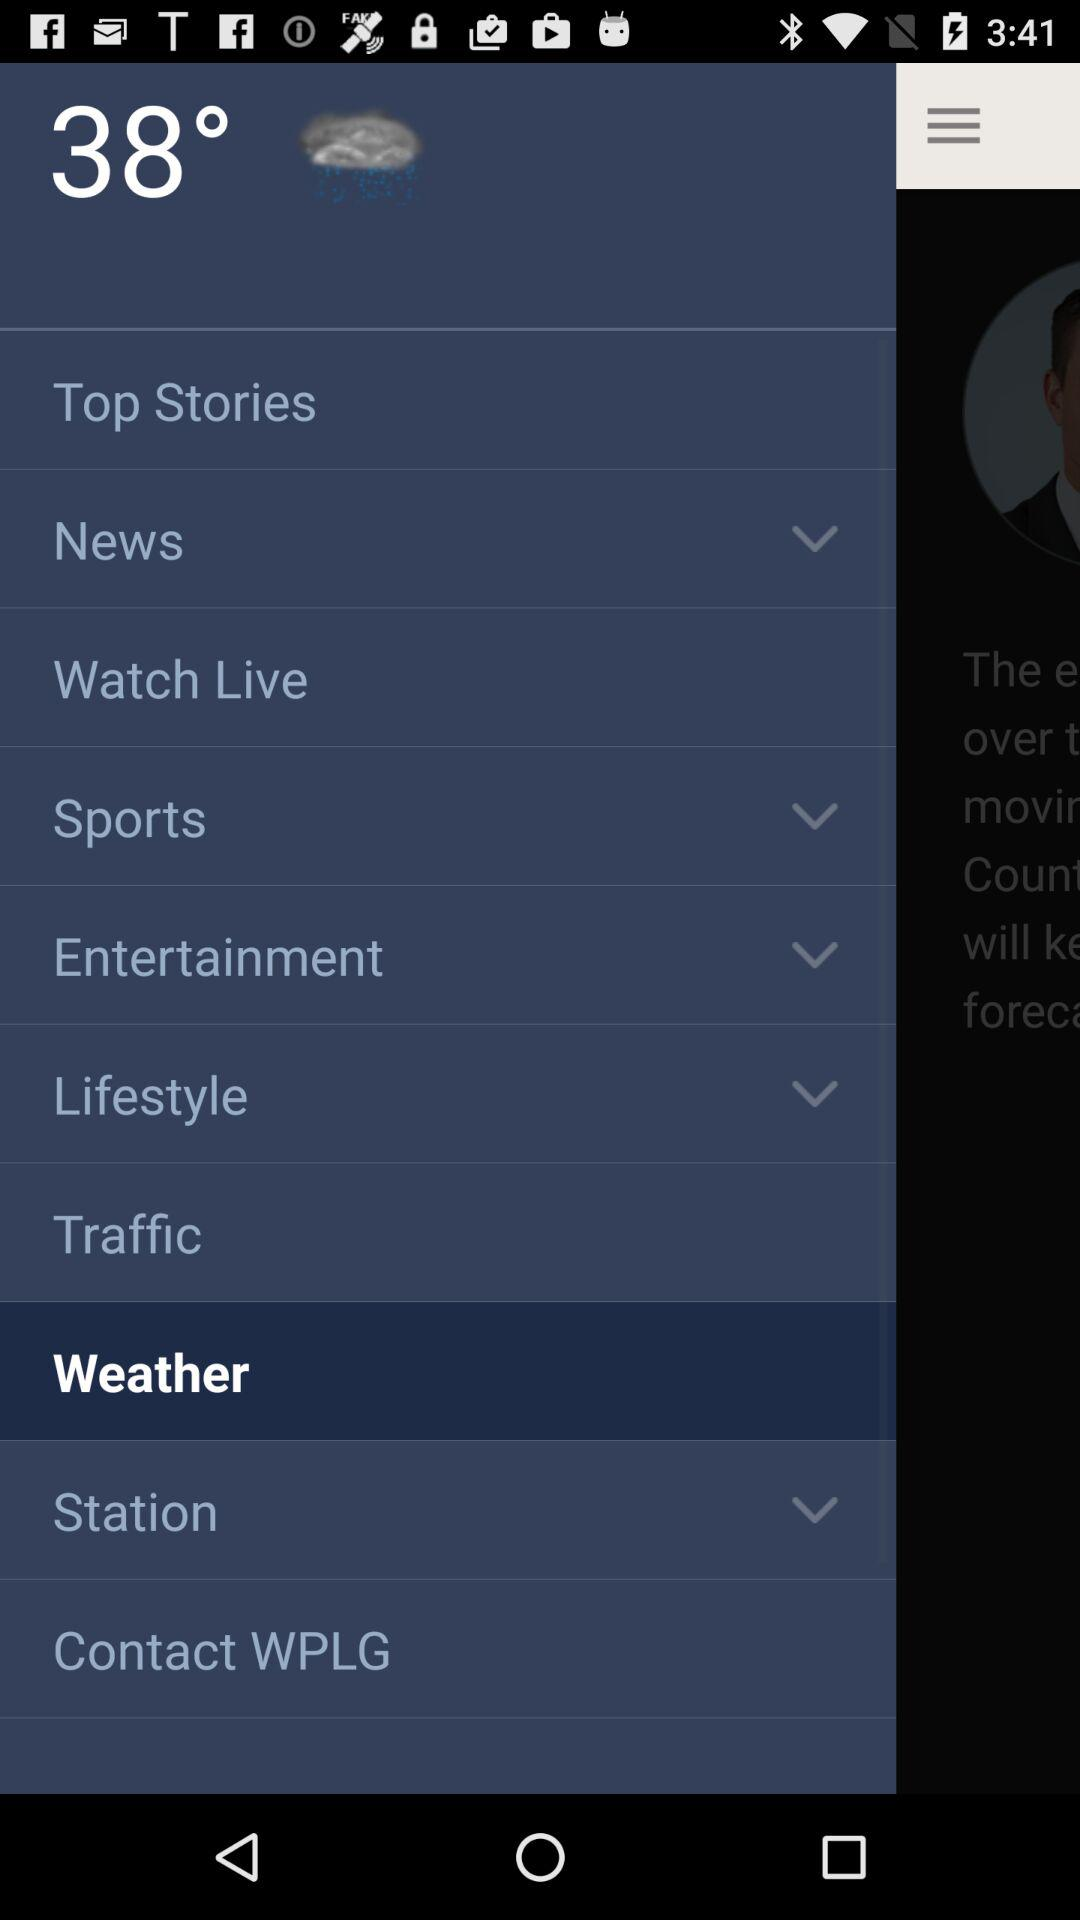How is the weather?
When the provided information is insufficient, respond with <no answer>. <no answer> 